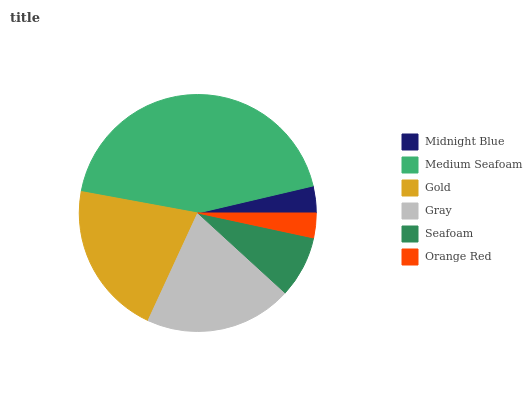Is Orange Red the minimum?
Answer yes or no. Yes. Is Medium Seafoam the maximum?
Answer yes or no. Yes. Is Gold the minimum?
Answer yes or no. No. Is Gold the maximum?
Answer yes or no. No. Is Medium Seafoam greater than Gold?
Answer yes or no. Yes. Is Gold less than Medium Seafoam?
Answer yes or no. Yes. Is Gold greater than Medium Seafoam?
Answer yes or no. No. Is Medium Seafoam less than Gold?
Answer yes or no. No. Is Gray the high median?
Answer yes or no. Yes. Is Seafoam the low median?
Answer yes or no. Yes. Is Medium Seafoam the high median?
Answer yes or no. No. Is Midnight Blue the low median?
Answer yes or no. No. 